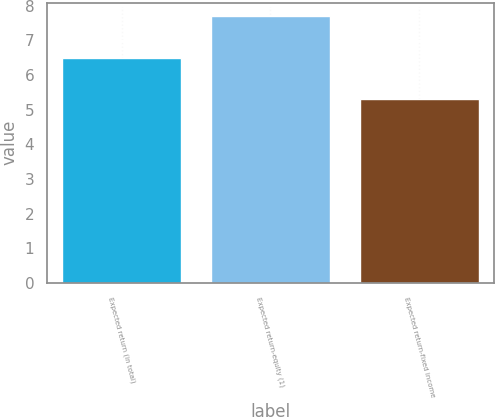Convert chart to OTSL. <chart><loc_0><loc_0><loc_500><loc_500><bar_chart><fcel>Expected return (in total)<fcel>Expected return-equity (1)<fcel>Expected return-fixed income<nl><fcel>6.5<fcel>7.7<fcel>5.3<nl></chart> 